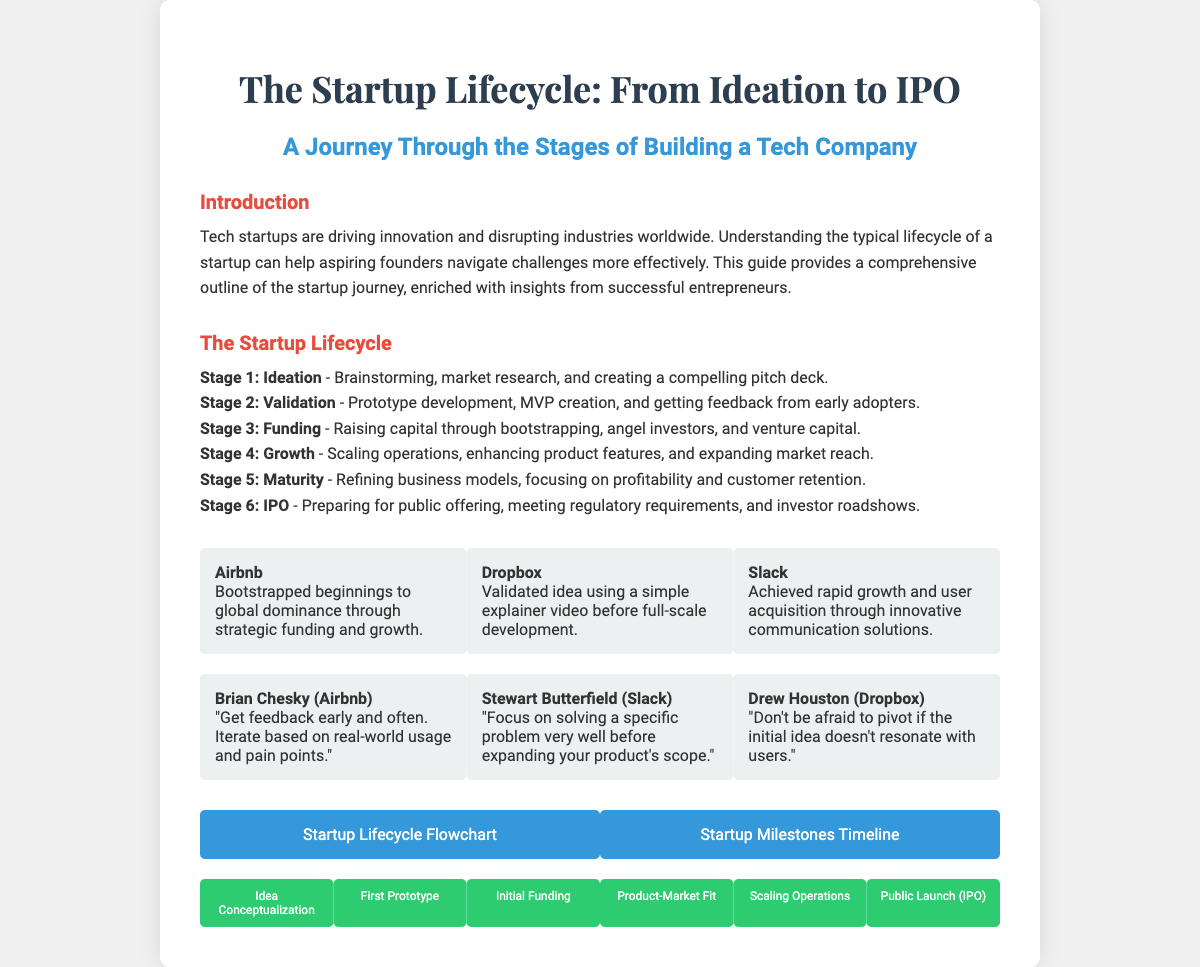What is the title of the document? The title appears prominently at the top of the document.
Answer: The Startup Lifecycle: From Ideation to IPO How many stages are in the startup lifecycle? The stages are listed in the section on "The Startup Lifecycle."
Answer: Six Who is the founder of Airbnb? The founder's name is mentioned in the tips section.
Answer: Brian Chesky What was Dropbox's strategy for validation? This information is provided in the case studies section.
Answer: Simple explainer video Which milestone marks the public launch? The milestones section outlines specific milestones in the startup journey.
Answer: Public Launch (IPO) What color is used for the section titles? The color used for section titles is explicitly mentioned in the styling indicated in the document.
Answer: Red Which case study mentions communication solutions? The case studies section provides details about specific startups and their stories.
Answer: Slack What is a common theme in the founder tips? Tips from founders highlight strategies and insights relevant to startups.
Answer: Feedback What is the visual item related to the startup lifecycle? The visuals section lists specific visuals designed to enhance understanding.
Answer: Startup Lifecycle Flowchart 